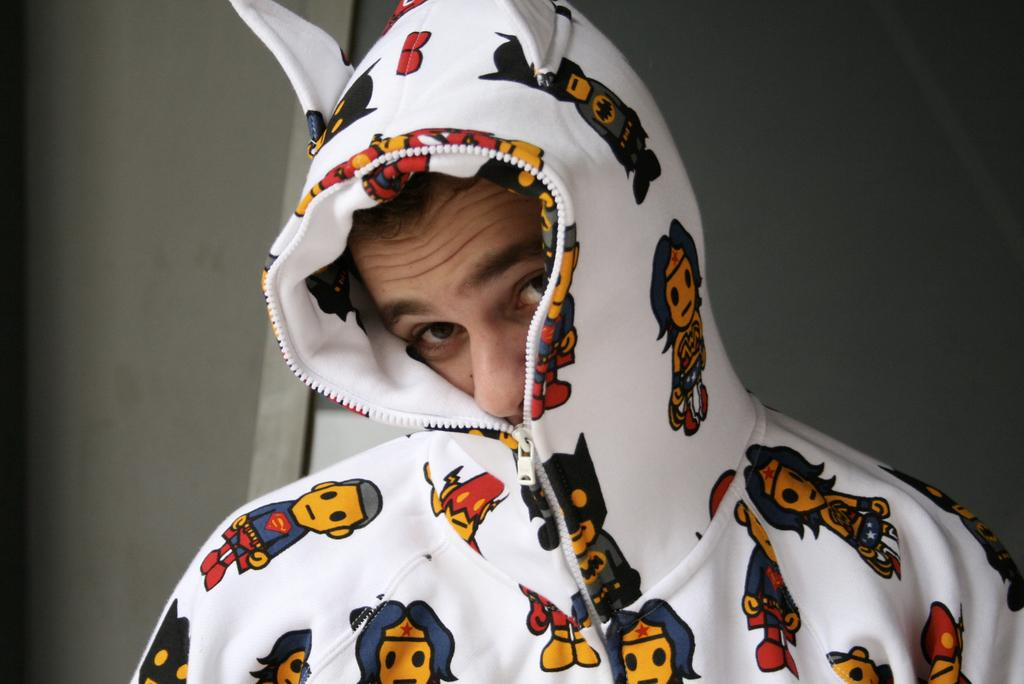Who or what is the main subject in the image? There is a person in the image. What is the person wearing? The person is wearing a jacket. What can be seen in the background of the image? There is a wall in the background of the image. What type of grain is being harvested by the woman in the image? There is no woman or grain present in the image; it features a person wearing a jacket with a wall in the background. 